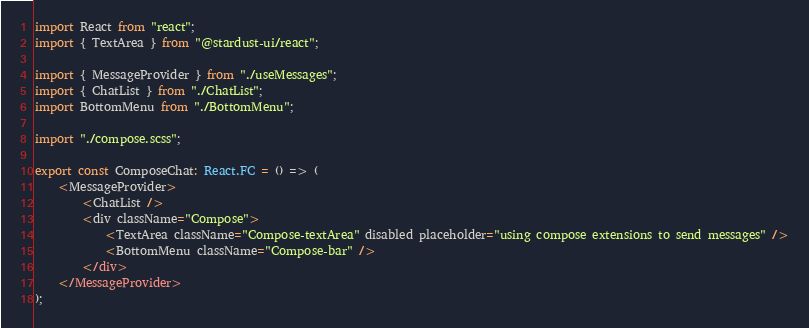Convert code to text. <code><loc_0><loc_0><loc_500><loc_500><_TypeScript_>import React from "react";
import { TextArea } from "@stardust-ui/react";

import { MessageProvider } from "./useMessages";
import { ChatList } from "./ChatList";
import BottomMenu from "./BottomMenu";

import "./compose.scss";

export const ComposeChat: React.FC = () => (
    <MessageProvider>
        <ChatList />
        <div className="Compose">
            <TextArea className="Compose-textArea" disabled placeholder="using compose extensions to send messages" />
            <BottomMenu className="Compose-bar" />
        </div>
    </MessageProvider>
);
</code> 